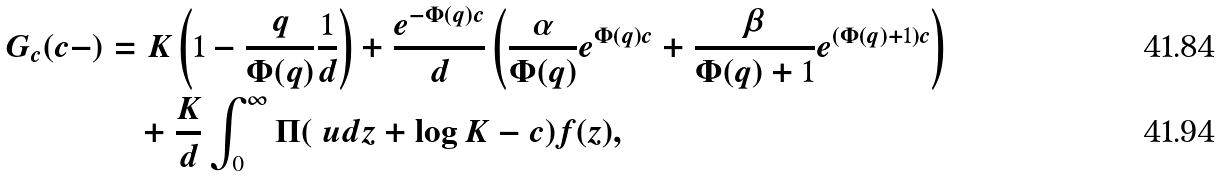Convert formula to latex. <formula><loc_0><loc_0><loc_500><loc_500>G _ { c } ( c - ) & = K \left ( 1 - \frac { q } { \Phi ( q ) } \frac { 1 } { d } \right ) + \frac { e ^ { - \Phi ( q ) c } } { d } \left ( \frac { \alpha } { \Phi ( q ) } e ^ { \Phi ( q ) c } + \frac { \beta } { \Phi ( q ) + 1 } e ^ { ( \Phi ( q ) + 1 ) c } \right ) \\ & \quad + \frac { K } { d } \int _ { 0 } ^ { \infty } \Pi ( \ u d z + \log K - c ) f ( z ) ,</formula> 